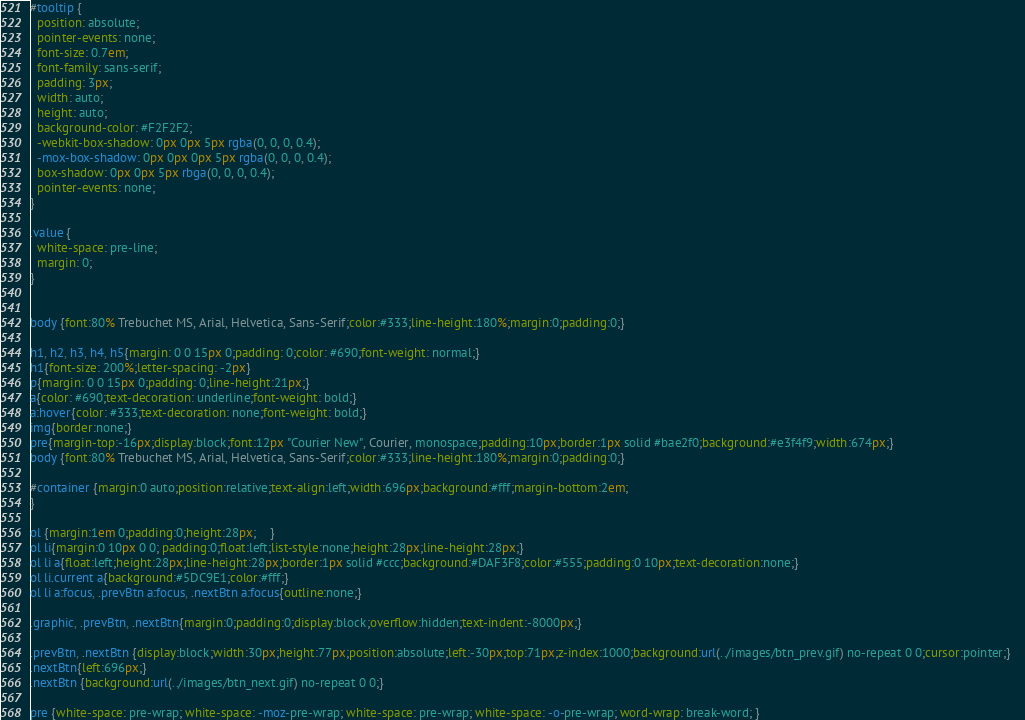Convert code to text. <code><loc_0><loc_0><loc_500><loc_500><_CSS_>#tooltip {
  position: absolute;
  pointer-events: none;
  font-size: 0.7em;
  font-family: sans-serif;
  padding: 3px;
  width: auto;
  height: auto;
  background-color: #F2F2F2;
  -webkit-box-shadow: 0px 0px 5px rgba(0, 0, 0, 0.4);
  -mox-box-shadow: 0px 0px 0px 5px rgba(0, 0, 0, 0.4);
  box-shadow: 0px 0px 5px rbga(0, 0, 0, 0.4);
  pointer-events: none;
}

.value {
  white-space: pre-line;
  margin: 0;
}


body {font:80% Trebuchet MS, Arial, Helvetica, Sans-Serif;color:#333;line-height:180%;margin:0;padding:0;}

h1, h2, h3, h4, h5{margin: 0 0 15px 0;padding: 0;color: #690;font-weight: normal;}
h1{font-size: 200%;letter-spacing: -2px}
p{margin: 0 0 15px 0;padding: 0;line-height:21px;}
a{color: #690;text-decoration: underline;font-weight: bold;}
a:hover{color: #333;text-decoration: none;font-weight: bold;}
img{border:none;}
pre{margin-top:-16px;display:block;font:12px "Courier New", Courier, monospace;padding:10px;border:1px solid #bae2f0;background:#e3f4f9;width:674px;}	
body {font:80% Trebuchet MS, Arial, Helvetica, Sans-Serif;color:#333;line-height:180%;margin:0;padding:0;}

#container {margin:0 auto;position:relative;text-align:left;width:696px;background:#fff;margin-bottom:2em;
}	

ol {margin:1em 0;padding:0;height:28px;	}
ol li{margin:0 10px 0 0; padding:0;float:left;list-style:none;height:28px;line-height:28px;}
ol li a{float:left;height:28px;line-height:28px;border:1px solid #ccc;background:#DAF3F8;color:#555;padding:0 10px;text-decoration:none;}
ol li.current a{background:#5DC9E1;color:#fff;}
ol li a:focus, .prevBtn a:focus, .nextBtn a:focus{outline:none;}

.graphic, .prevBtn, .nextBtn{margin:0;padding:0;display:block;overflow:hidden;text-indent:-8000px;}

.prevBtn, .nextBtn {display:block;width:30px;height:77px;position:absolute;left:-30px;top:71px;z-index:1000;background:url(../images/btn_prev.gif) no-repeat 0 0;cursor:pointer;}	
.nextBtn{left:696px;}														
.nextBtn {background:url(../images/btn_next.gif) no-repeat 0 0;}	

pre {white-space: pre-wrap; white-space: -moz-pre-wrap; white-space: pre-wrap; white-space: -o-pre-wrap; word-wrap: break-word; }</code> 